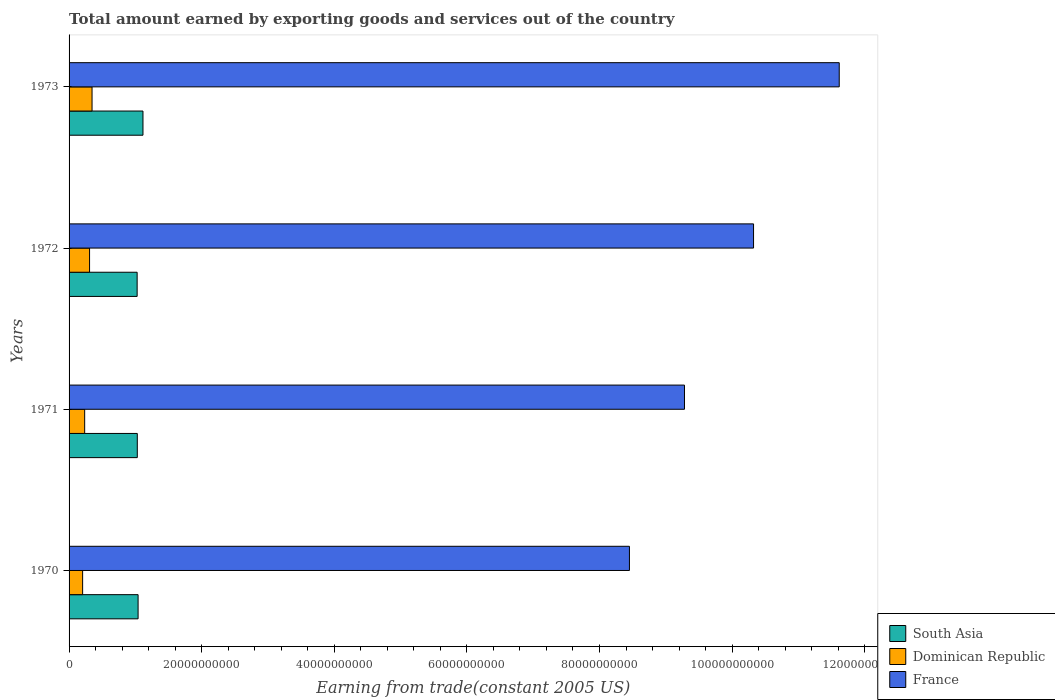How many different coloured bars are there?
Give a very brief answer. 3. Are the number of bars on each tick of the Y-axis equal?
Your answer should be compact. Yes. How many bars are there on the 2nd tick from the top?
Provide a short and direct response. 3. How many bars are there on the 3rd tick from the bottom?
Your response must be concise. 3. What is the label of the 4th group of bars from the top?
Offer a terse response. 1970. In how many cases, is the number of bars for a given year not equal to the number of legend labels?
Ensure brevity in your answer.  0. What is the total amount earned by exporting goods and services in South Asia in 1973?
Your answer should be compact. 1.11e+1. Across all years, what is the maximum total amount earned by exporting goods and services in France?
Your answer should be compact. 1.16e+11. Across all years, what is the minimum total amount earned by exporting goods and services in France?
Offer a terse response. 8.45e+1. In which year was the total amount earned by exporting goods and services in South Asia maximum?
Offer a very short reply. 1973. In which year was the total amount earned by exporting goods and services in Dominican Republic minimum?
Offer a terse response. 1970. What is the total total amount earned by exporting goods and services in Dominican Republic in the graph?
Provide a short and direct response. 1.10e+1. What is the difference between the total amount earned by exporting goods and services in South Asia in 1970 and that in 1972?
Your response must be concise. 1.43e+08. What is the difference between the total amount earned by exporting goods and services in South Asia in 1970 and the total amount earned by exporting goods and services in Dominican Republic in 1972?
Provide a succinct answer. 7.32e+09. What is the average total amount earned by exporting goods and services in South Asia per year?
Offer a terse response. 1.05e+1. In the year 1971, what is the difference between the total amount earned by exporting goods and services in South Asia and total amount earned by exporting goods and services in France?
Make the answer very short. -8.25e+1. What is the ratio of the total amount earned by exporting goods and services in Dominican Republic in 1971 to that in 1973?
Give a very brief answer. 0.68. What is the difference between the highest and the second highest total amount earned by exporting goods and services in South Asia?
Provide a succinct answer. 7.36e+08. What is the difference between the highest and the lowest total amount earned by exporting goods and services in Dominican Republic?
Your answer should be compact. 1.42e+09. What does the 3rd bar from the top in 1973 represents?
Your answer should be very brief. South Asia. What does the 2nd bar from the bottom in 1971 represents?
Offer a very short reply. Dominican Republic. Are all the bars in the graph horizontal?
Ensure brevity in your answer.  Yes. How many years are there in the graph?
Provide a short and direct response. 4. Are the values on the major ticks of X-axis written in scientific E-notation?
Ensure brevity in your answer.  No. Does the graph contain any zero values?
Provide a short and direct response. No. Where does the legend appear in the graph?
Offer a terse response. Bottom right. How are the legend labels stacked?
Give a very brief answer. Vertical. What is the title of the graph?
Make the answer very short. Total amount earned by exporting goods and services out of the country. What is the label or title of the X-axis?
Your response must be concise. Earning from trade(constant 2005 US). What is the label or title of the Y-axis?
Offer a very short reply. Years. What is the Earning from trade(constant 2005 US) in South Asia in 1970?
Provide a short and direct response. 1.04e+1. What is the Earning from trade(constant 2005 US) in Dominican Republic in 1970?
Your answer should be very brief. 2.04e+09. What is the Earning from trade(constant 2005 US) of France in 1970?
Offer a very short reply. 8.45e+1. What is the Earning from trade(constant 2005 US) of South Asia in 1971?
Offer a very short reply. 1.03e+1. What is the Earning from trade(constant 2005 US) in Dominican Republic in 1971?
Ensure brevity in your answer.  2.35e+09. What is the Earning from trade(constant 2005 US) of France in 1971?
Offer a terse response. 9.28e+1. What is the Earning from trade(constant 2005 US) of South Asia in 1972?
Offer a very short reply. 1.03e+1. What is the Earning from trade(constant 2005 US) of Dominican Republic in 1972?
Provide a succinct answer. 3.09e+09. What is the Earning from trade(constant 2005 US) of France in 1972?
Your answer should be very brief. 1.03e+11. What is the Earning from trade(constant 2005 US) of South Asia in 1973?
Provide a succinct answer. 1.11e+1. What is the Earning from trade(constant 2005 US) in Dominican Republic in 1973?
Your answer should be very brief. 3.47e+09. What is the Earning from trade(constant 2005 US) of France in 1973?
Your answer should be very brief. 1.16e+11. Across all years, what is the maximum Earning from trade(constant 2005 US) in South Asia?
Make the answer very short. 1.11e+1. Across all years, what is the maximum Earning from trade(constant 2005 US) of Dominican Republic?
Offer a very short reply. 3.47e+09. Across all years, what is the maximum Earning from trade(constant 2005 US) of France?
Give a very brief answer. 1.16e+11. Across all years, what is the minimum Earning from trade(constant 2005 US) in South Asia?
Make the answer very short. 1.03e+1. Across all years, what is the minimum Earning from trade(constant 2005 US) in Dominican Republic?
Your answer should be very brief. 2.04e+09. Across all years, what is the minimum Earning from trade(constant 2005 US) in France?
Provide a short and direct response. 8.45e+1. What is the total Earning from trade(constant 2005 US) of South Asia in the graph?
Your answer should be very brief. 4.21e+1. What is the total Earning from trade(constant 2005 US) of Dominican Republic in the graph?
Keep it short and to the point. 1.10e+1. What is the total Earning from trade(constant 2005 US) in France in the graph?
Make the answer very short. 3.97e+11. What is the difference between the Earning from trade(constant 2005 US) of South Asia in 1970 and that in 1971?
Give a very brief answer. 1.19e+08. What is the difference between the Earning from trade(constant 2005 US) of Dominican Republic in 1970 and that in 1971?
Provide a short and direct response. -3.10e+08. What is the difference between the Earning from trade(constant 2005 US) in France in 1970 and that in 1971?
Offer a terse response. -8.30e+09. What is the difference between the Earning from trade(constant 2005 US) in South Asia in 1970 and that in 1972?
Your answer should be compact. 1.43e+08. What is the difference between the Earning from trade(constant 2005 US) in Dominican Republic in 1970 and that in 1972?
Keep it short and to the point. -1.05e+09. What is the difference between the Earning from trade(constant 2005 US) in France in 1970 and that in 1972?
Ensure brevity in your answer.  -1.87e+1. What is the difference between the Earning from trade(constant 2005 US) of South Asia in 1970 and that in 1973?
Your answer should be very brief. -7.36e+08. What is the difference between the Earning from trade(constant 2005 US) in Dominican Republic in 1970 and that in 1973?
Make the answer very short. -1.42e+09. What is the difference between the Earning from trade(constant 2005 US) in France in 1970 and that in 1973?
Your answer should be compact. -3.16e+1. What is the difference between the Earning from trade(constant 2005 US) in South Asia in 1971 and that in 1972?
Offer a terse response. 2.44e+07. What is the difference between the Earning from trade(constant 2005 US) of Dominican Republic in 1971 and that in 1972?
Provide a short and direct response. -7.36e+08. What is the difference between the Earning from trade(constant 2005 US) in France in 1971 and that in 1972?
Ensure brevity in your answer.  -1.04e+1. What is the difference between the Earning from trade(constant 2005 US) in South Asia in 1971 and that in 1973?
Make the answer very short. -8.55e+08. What is the difference between the Earning from trade(constant 2005 US) in Dominican Republic in 1971 and that in 1973?
Give a very brief answer. -1.11e+09. What is the difference between the Earning from trade(constant 2005 US) of France in 1971 and that in 1973?
Offer a terse response. -2.33e+1. What is the difference between the Earning from trade(constant 2005 US) in South Asia in 1972 and that in 1973?
Your answer should be very brief. -8.79e+08. What is the difference between the Earning from trade(constant 2005 US) of Dominican Republic in 1972 and that in 1973?
Offer a very short reply. -3.76e+08. What is the difference between the Earning from trade(constant 2005 US) in France in 1972 and that in 1973?
Offer a terse response. -1.29e+1. What is the difference between the Earning from trade(constant 2005 US) of South Asia in 1970 and the Earning from trade(constant 2005 US) of Dominican Republic in 1971?
Provide a short and direct response. 8.06e+09. What is the difference between the Earning from trade(constant 2005 US) of South Asia in 1970 and the Earning from trade(constant 2005 US) of France in 1971?
Your response must be concise. -8.24e+1. What is the difference between the Earning from trade(constant 2005 US) of Dominican Republic in 1970 and the Earning from trade(constant 2005 US) of France in 1971?
Offer a very short reply. -9.08e+1. What is the difference between the Earning from trade(constant 2005 US) of South Asia in 1970 and the Earning from trade(constant 2005 US) of Dominican Republic in 1972?
Provide a short and direct response. 7.32e+09. What is the difference between the Earning from trade(constant 2005 US) in South Asia in 1970 and the Earning from trade(constant 2005 US) in France in 1972?
Your answer should be very brief. -9.28e+1. What is the difference between the Earning from trade(constant 2005 US) of Dominican Republic in 1970 and the Earning from trade(constant 2005 US) of France in 1972?
Your answer should be very brief. -1.01e+11. What is the difference between the Earning from trade(constant 2005 US) of South Asia in 1970 and the Earning from trade(constant 2005 US) of Dominican Republic in 1973?
Provide a succinct answer. 6.94e+09. What is the difference between the Earning from trade(constant 2005 US) in South Asia in 1970 and the Earning from trade(constant 2005 US) in France in 1973?
Your answer should be very brief. -1.06e+11. What is the difference between the Earning from trade(constant 2005 US) of Dominican Republic in 1970 and the Earning from trade(constant 2005 US) of France in 1973?
Offer a terse response. -1.14e+11. What is the difference between the Earning from trade(constant 2005 US) of South Asia in 1971 and the Earning from trade(constant 2005 US) of Dominican Republic in 1972?
Make the answer very short. 7.20e+09. What is the difference between the Earning from trade(constant 2005 US) of South Asia in 1971 and the Earning from trade(constant 2005 US) of France in 1972?
Provide a short and direct response. -9.29e+1. What is the difference between the Earning from trade(constant 2005 US) of Dominican Republic in 1971 and the Earning from trade(constant 2005 US) of France in 1972?
Provide a short and direct response. -1.01e+11. What is the difference between the Earning from trade(constant 2005 US) in South Asia in 1971 and the Earning from trade(constant 2005 US) in Dominican Republic in 1973?
Offer a very short reply. 6.83e+09. What is the difference between the Earning from trade(constant 2005 US) in South Asia in 1971 and the Earning from trade(constant 2005 US) in France in 1973?
Provide a short and direct response. -1.06e+11. What is the difference between the Earning from trade(constant 2005 US) in Dominican Republic in 1971 and the Earning from trade(constant 2005 US) in France in 1973?
Your answer should be very brief. -1.14e+11. What is the difference between the Earning from trade(constant 2005 US) in South Asia in 1972 and the Earning from trade(constant 2005 US) in Dominican Republic in 1973?
Provide a short and direct response. 6.80e+09. What is the difference between the Earning from trade(constant 2005 US) in South Asia in 1972 and the Earning from trade(constant 2005 US) in France in 1973?
Your response must be concise. -1.06e+11. What is the difference between the Earning from trade(constant 2005 US) of Dominican Republic in 1972 and the Earning from trade(constant 2005 US) of France in 1973?
Ensure brevity in your answer.  -1.13e+11. What is the average Earning from trade(constant 2005 US) of South Asia per year?
Give a very brief answer. 1.05e+1. What is the average Earning from trade(constant 2005 US) of Dominican Republic per year?
Offer a very short reply. 2.74e+09. What is the average Earning from trade(constant 2005 US) of France per year?
Keep it short and to the point. 9.92e+1. In the year 1970, what is the difference between the Earning from trade(constant 2005 US) of South Asia and Earning from trade(constant 2005 US) of Dominican Republic?
Ensure brevity in your answer.  8.37e+09. In the year 1970, what is the difference between the Earning from trade(constant 2005 US) of South Asia and Earning from trade(constant 2005 US) of France?
Give a very brief answer. -7.41e+1. In the year 1970, what is the difference between the Earning from trade(constant 2005 US) in Dominican Republic and Earning from trade(constant 2005 US) in France?
Your answer should be very brief. -8.25e+1. In the year 1971, what is the difference between the Earning from trade(constant 2005 US) of South Asia and Earning from trade(constant 2005 US) of Dominican Republic?
Provide a succinct answer. 7.94e+09. In the year 1971, what is the difference between the Earning from trade(constant 2005 US) in South Asia and Earning from trade(constant 2005 US) in France?
Ensure brevity in your answer.  -8.25e+1. In the year 1971, what is the difference between the Earning from trade(constant 2005 US) of Dominican Republic and Earning from trade(constant 2005 US) of France?
Give a very brief answer. -9.05e+1. In the year 1972, what is the difference between the Earning from trade(constant 2005 US) in South Asia and Earning from trade(constant 2005 US) in Dominican Republic?
Keep it short and to the point. 7.18e+09. In the year 1972, what is the difference between the Earning from trade(constant 2005 US) in South Asia and Earning from trade(constant 2005 US) in France?
Your answer should be very brief. -9.30e+1. In the year 1972, what is the difference between the Earning from trade(constant 2005 US) of Dominican Republic and Earning from trade(constant 2005 US) of France?
Keep it short and to the point. -1.00e+11. In the year 1973, what is the difference between the Earning from trade(constant 2005 US) of South Asia and Earning from trade(constant 2005 US) of Dominican Republic?
Offer a terse response. 7.68e+09. In the year 1973, what is the difference between the Earning from trade(constant 2005 US) in South Asia and Earning from trade(constant 2005 US) in France?
Provide a succinct answer. -1.05e+11. In the year 1973, what is the difference between the Earning from trade(constant 2005 US) in Dominican Republic and Earning from trade(constant 2005 US) in France?
Ensure brevity in your answer.  -1.13e+11. What is the ratio of the Earning from trade(constant 2005 US) of South Asia in 1970 to that in 1971?
Your response must be concise. 1.01. What is the ratio of the Earning from trade(constant 2005 US) in Dominican Republic in 1970 to that in 1971?
Offer a very short reply. 0.87. What is the ratio of the Earning from trade(constant 2005 US) of France in 1970 to that in 1971?
Offer a very short reply. 0.91. What is the ratio of the Earning from trade(constant 2005 US) of South Asia in 1970 to that in 1972?
Your answer should be very brief. 1.01. What is the ratio of the Earning from trade(constant 2005 US) in Dominican Republic in 1970 to that in 1972?
Offer a terse response. 0.66. What is the ratio of the Earning from trade(constant 2005 US) of France in 1970 to that in 1972?
Offer a terse response. 0.82. What is the ratio of the Earning from trade(constant 2005 US) in South Asia in 1970 to that in 1973?
Your answer should be very brief. 0.93. What is the ratio of the Earning from trade(constant 2005 US) of Dominican Republic in 1970 to that in 1973?
Your answer should be compact. 0.59. What is the ratio of the Earning from trade(constant 2005 US) of France in 1970 to that in 1973?
Make the answer very short. 0.73. What is the ratio of the Earning from trade(constant 2005 US) of Dominican Republic in 1971 to that in 1972?
Make the answer very short. 0.76. What is the ratio of the Earning from trade(constant 2005 US) of France in 1971 to that in 1972?
Provide a succinct answer. 0.9. What is the ratio of the Earning from trade(constant 2005 US) of South Asia in 1971 to that in 1973?
Your answer should be very brief. 0.92. What is the ratio of the Earning from trade(constant 2005 US) of Dominican Republic in 1971 to that in 1973?
Your answer should be compact. 0.68. What is the ratio of the Earning from trade(constant 2005 US) in France in 1971 to that in 1973?
Your answer should be very brief. 0.8. What is the ratio of the Earning from trade(constant 2005 US) in South Asia in 1972 to that in 1973?
Ensure brevity in your answer.  0.92. What is the ratio of the Earning from trade(constant 2005 US) in Dominican Republic in 1972 to that in 1973?
Ensure brevity in your answer.  0.89. What is the ratio of the Earning from trade(constant 2005 US) in France in 1972 to that in 1973?
Your answer should be compact. 0.89. What is the difference between the highest and the second highest Earning from trade(constant 2005 US) in South Asia?
Offer a very short reply. 7.36e+08. What is the difference between the highest and the second highest Earning from trade(constant 2005 US) of Dominican Republic?
Keep it short and to the point. 3.76e+08. What is the difference between the highest and the second highest Earning from trade(constant 2005 US) of France?
Ensure brevity in your answer.  1.29e+1. What is the difference between the highest and the lowest Earning from trade(constant 2005 US) in South Asia?
Give a very brief answer. 8.79e+08. What is the difference between the highest and the lowest Earning from trade(constant 2005 US) in Dominican Republic?
Ensure brevity in your answer.  1.42e+09. What is the difference between the highest and the lowest Earning from trade(constant 2005 US) of France?
Your answer should be compact. 3.16e+1. 